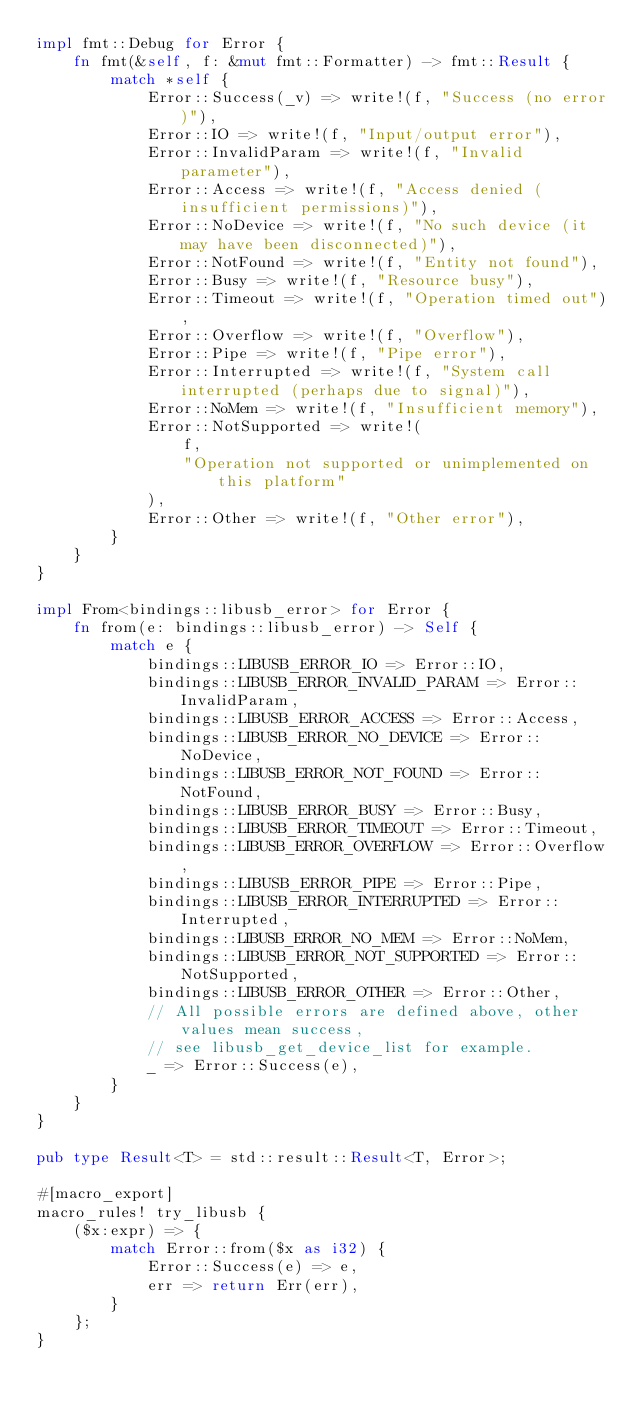Convert code to text. <code><loc_0><loc_0><loc_500><loc_500><_Rust_>impl fmt::Debug for Error {
    fn fmt(&self, f: &mut fmt::Formatter) -> fmt::Result {
        match *self {
            Error::Success(_v) => write!(f, "Success (no error)"),
            Error::IO => write!(f, "Input/output error"),
            Error::InvalidParam => write!(f, "Invalid parameter"),
            Error::Access => write!(f, "Access denied (insufficient permissions)"),
            Error::NoDevice => write!(f, "No such device (it may have been disconnected)"),
            Error::NotFound => write!(f, "Entity not found"),
            Error::Busy => write!(f, "Resource busy"),
            Error::Timeout => write!(f, "Operation timed out"),
            Error::Overflow => write!(f, "Overflow"),
            Error::Pipe => write!(f, "Pipe error"),
            Error::Interrupted => write!(f, "System call interrupted (perhaps due to signal)"),
            Error::NoMem => write!(f, "Insufficient memory"),
            Error::NotSupported => write!(
                f,
                "Operation not supported or unimplemented on this platform"
            ),
            Error::Other => write!(f, "Other error"),
        }
    }
}

impl From<bindings::libusb_error> for Error {
    fn from(e: bindings::libusb_error) -> Self {
        match e {
            bindings::LIBUSB_ERROR_IO => Error::IO,
            bindings::LIBUSB_ERROR_INVALID_PARAM => Error::InvalidParam,
            bindings::LIBUSB_ERROR_ACCESS => Error::Access,
            bindings::LIBUSB_ERROR_NO_DEVICE => Error::NoDevice,
            bindings::LIBUSB_ERROR_NOT_FOUND => Error::NotFound,
            bindings::LIBUSB_ERROR_BUSY => Error::Busy,
            bindings::LIBUSB_ERROR_TIMEOUT => Error::Timeout,
            bindings::LIBUSB_ERROR_OVERFLOW => Error::Overflow,
            bindings::LIBUSB_ERROR_PIPE => Error::Pipe,
            bindings::LIBUSB_ERROR_INTERRUPTED => Error::Interrupted,
            bindings::LIBUSB_ERROR_NO_MEM => Error::NoMem,
            bindings::LIBUSB_ERROR_NOT_SUPPORTED => Error::NotSupported,
            bindings::LIBUSB_ERROR_OTHER => Error::Other,
            // All possible errors are defined above, other values mean success,
            // see libusb_get_device_list for example.
            _ => Error::Success(e),
        }
    }
}

pub type Result<T> = std::result::Result<T, Error>;

#[macro_export]
macro_rules! try_libusb {
    ($x:expr) => {
        match Error::from($x as i32) {
            Error::Success(e) => e,
            err => return Err(err),
        }
    };
}
</code> 